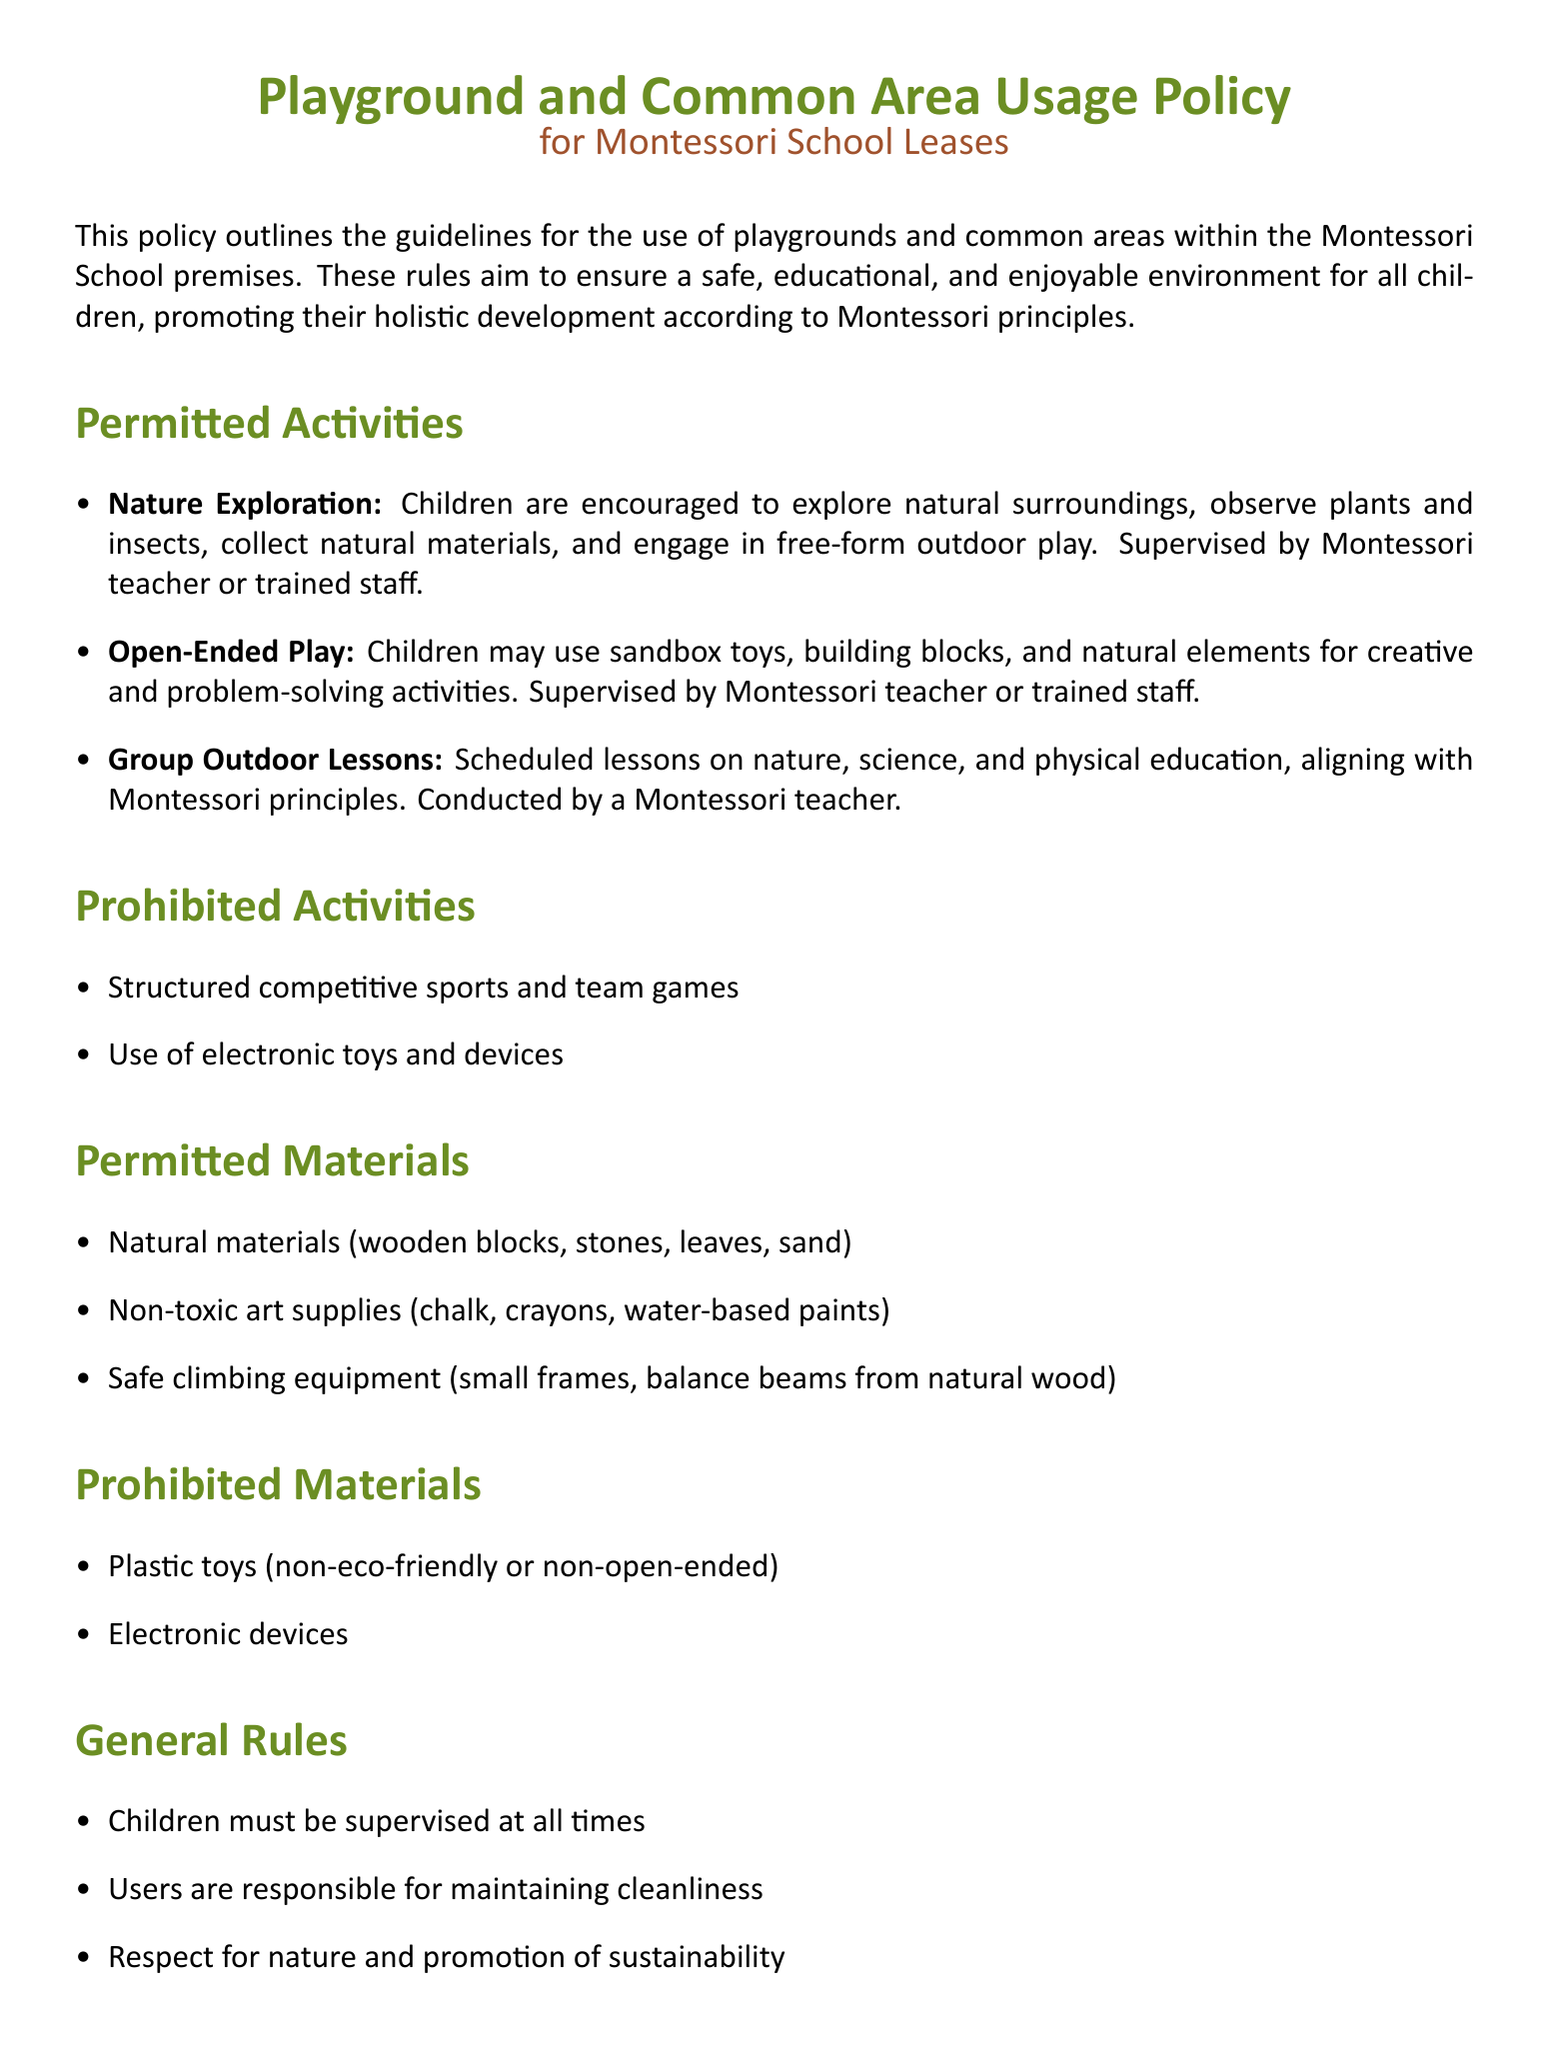What are the permitted activities for children? The document lists nature exploration, open-ended play, and group outdoor lessons as permitted activities for children.
Answer: Nature exploration, open-ended play, group outdoor lessons Who is responsible for supervising children during activities? The policy specifies that activities should be supervised by a Montessori teacher or trained staff.
Answer: Montessori teacher or trained staff What type of materials are allowed for outdoor play? The document specifies natural materials, non-toxic art supplies, and safe climbing equipment as permitted materials.
Answer: Natural materials, non-toxic art supplies, safe climbing equipment What is prohibited in the playground usage? The document clearly states structured competitive sports and team games, as well as the use of electronic toys and devices, are prohibited.
Answer: Structured competitive sports and team games, electronic toys and devices What must users do regarding cleanliness? The policy emphasizes that users are responsible for maintaining cleanliness in the playground and common areas.
Answer: Maintaining cleanliness How should children interact with nature according to the policy? The document encourages children to respect nature and promote sustainability, indicating a specific approach to interaction.
Answer: Respect for nature, promote sustainability What should always be present when children are using the playground? The general rules include the requirement for children to always be supervised.
Answer: Supervision What type of toys are explicitly prohibited? The policy prohibits plastic toys that are non-eco-friendly or non-open-ended.
Answer: Plastic toys (non-eco-friendly or non-open-ended) 